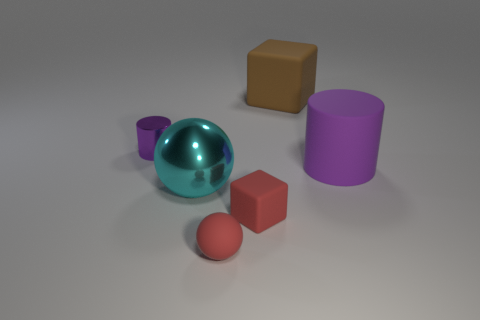Can you describe the relative sizes of the objects? Certainly! The image shows objects of varying sizes: the largest one appears to be the purple cylinder, followed by the teal sphere. The red cube and tiny purple cylinder are smaller, and the smallest object is the salmon-colored sphere. 